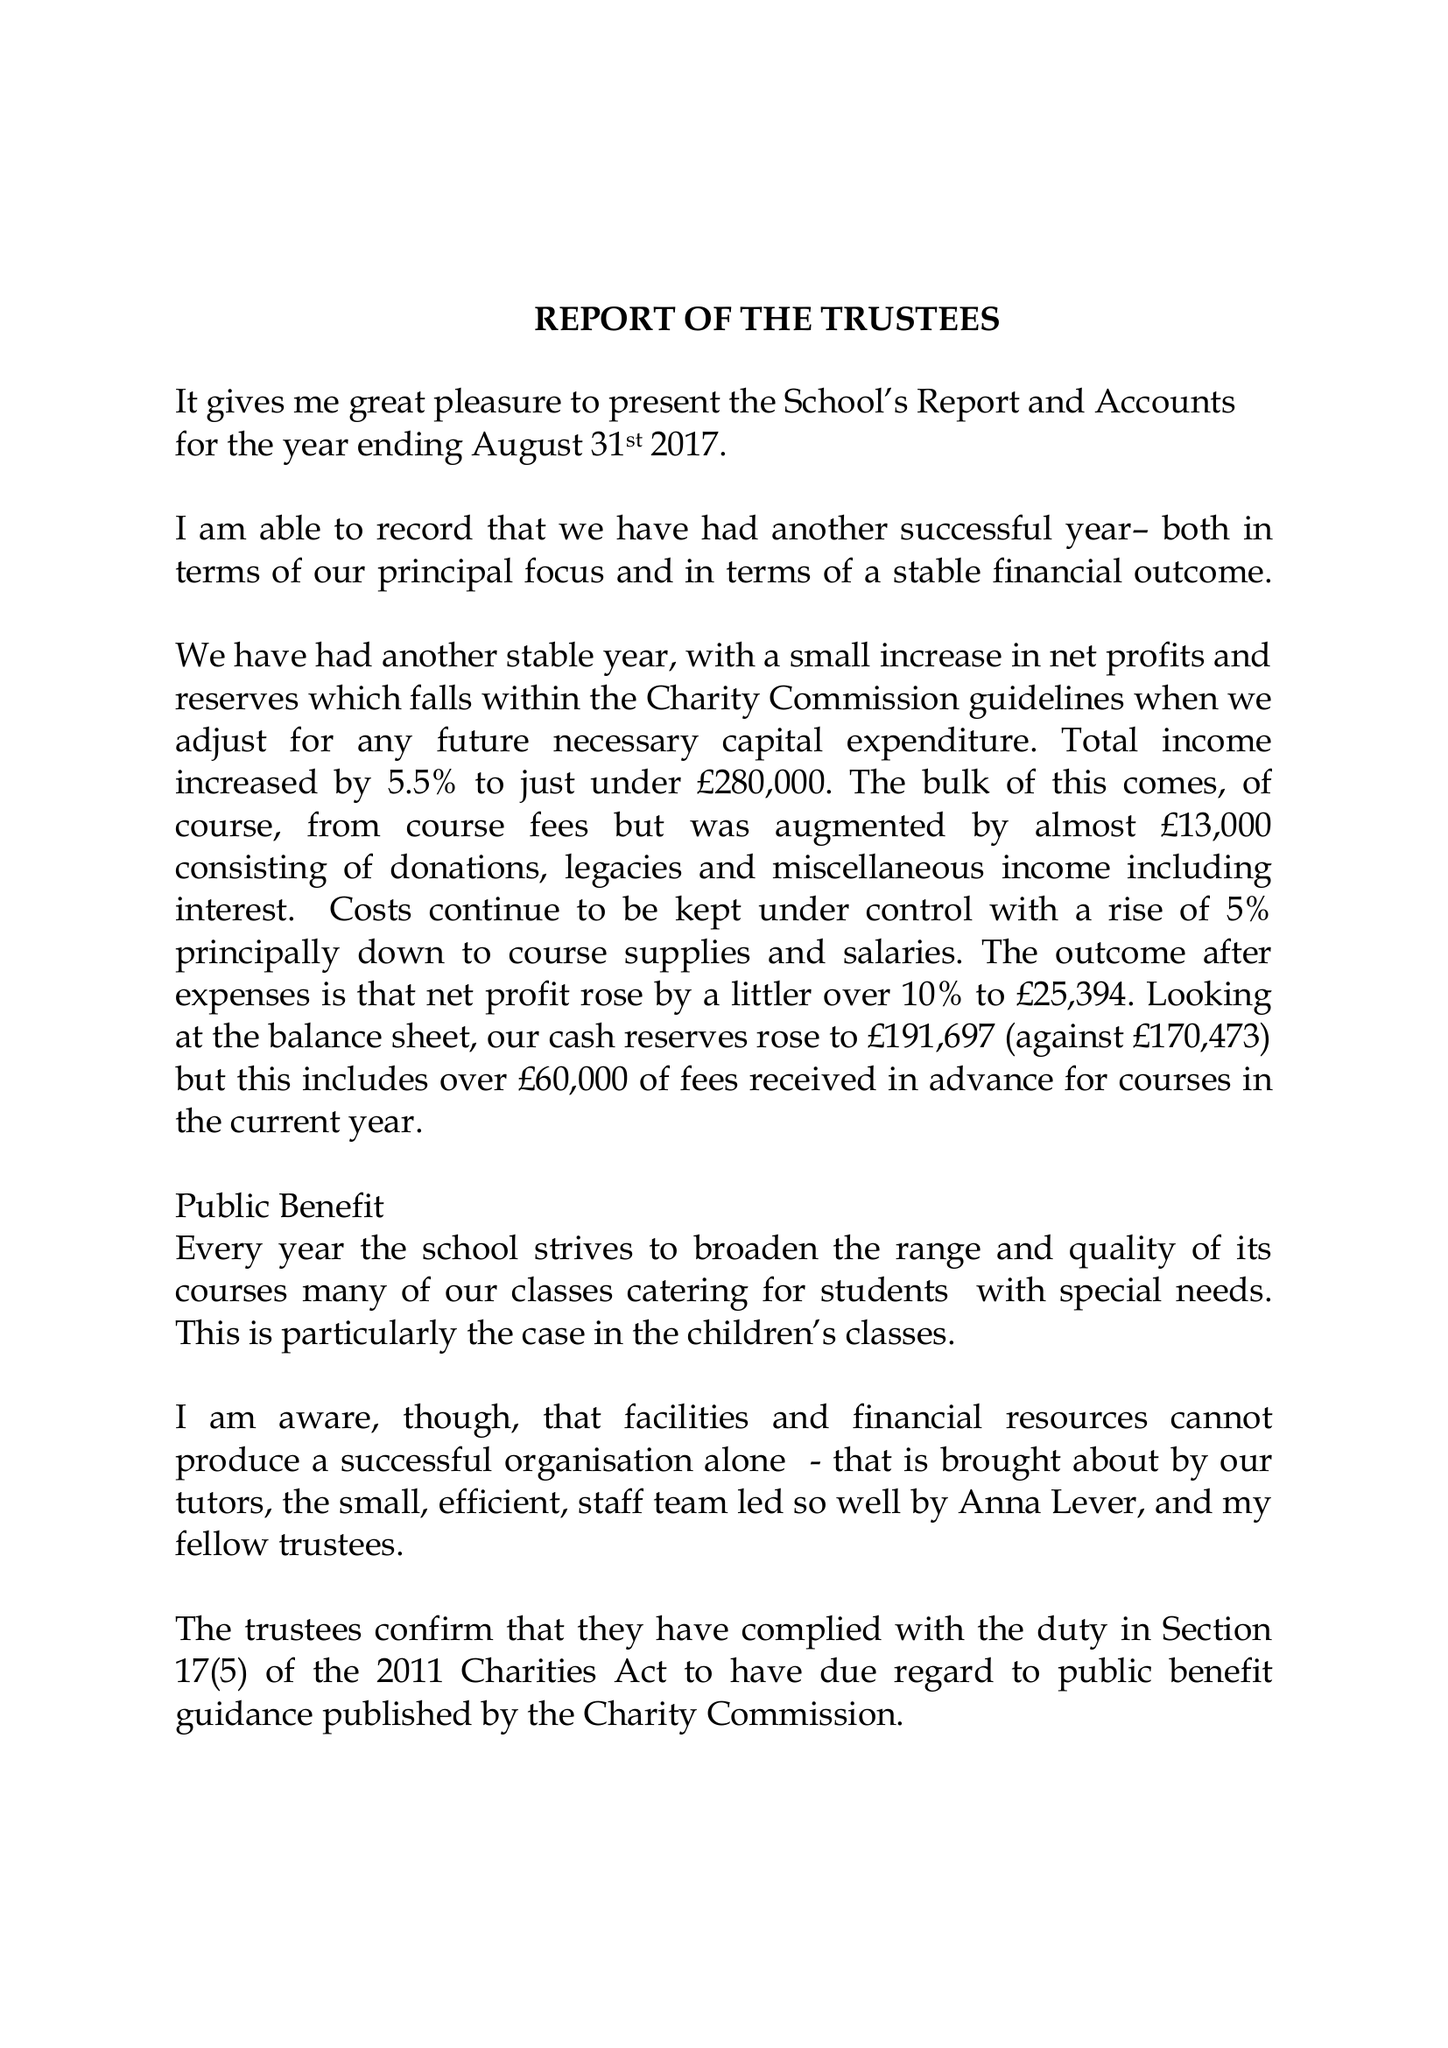What is the value for the address__street_line?
Answer the question using a single word or phrase. None 